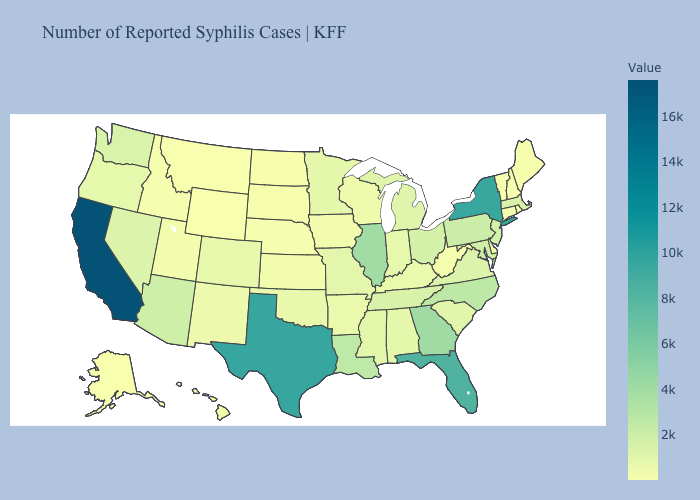Among the states that border New York , does Vermont have the lowest value?
Keep it brief. Yes. Which states have the highest value in the USA?
Short answer required. California. Does Texas have the highest value in the South?
Write a very short answer. Yes. 